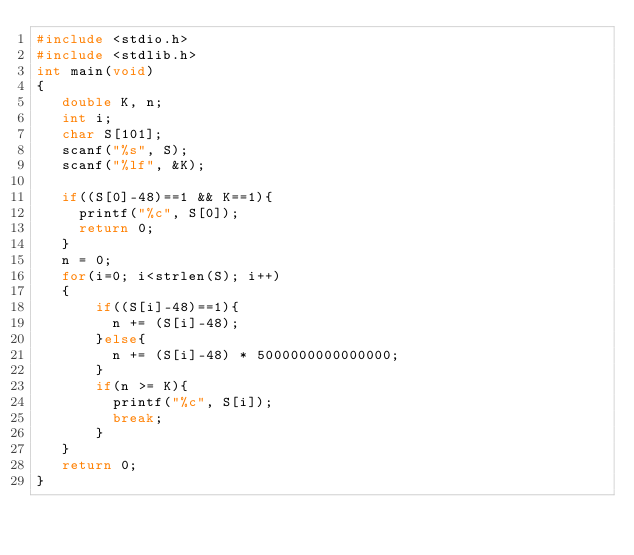Convert code to text. <code><loc_0><loc_0><loc_500><loc_500><_C_>#include <stdio.h>
#include <stdlib.h>
int main(void)
{
   double K, n;
   int i;
   char S[101];
   scanf("%s", S);
   scanf("%lf", &K);
   
   if((S[0]-48)==1 && K==1){
     printf("%c", S[0]);
     return 0;
   }
   n = 0;
   for(i=0; i<strlen(S); i++)
   {
       if((S[i]-48)==1){
         n += (S[i]-48);
       }else{
         n += (S[i]-48) * 5000000000000000;
       }
       if(n >= K){
         printf("%c", S[i]);
         break;
       }
   }
   return 0;
}
</code> 